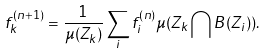Convert formula to latex. <formula><loc_0><loc_0><loc_500><loc_500>f _ { k } ^ { ( n + 1 ) } = \frac { 1 } { \mu ( Z _ { k } ) } \sum _ { i } f _ { i } ^ { ( n ) } \mu ( Z _ { k } \bigcap B ( Z _ { i } ) ) .</formula> 